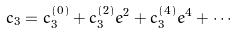Convert formula to latex. <formula><loc_0><loc_0><loc_500><loc_500>c _ { 3 } = c _ { 3 } ^ { ( 0 ) } + c _ { 3 } ^ { ( 2 ) } e ^ { 2 } + c _ { 3 } ^ { ( 4 ) } e ^ { 4 } + \cdots</formula> 